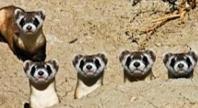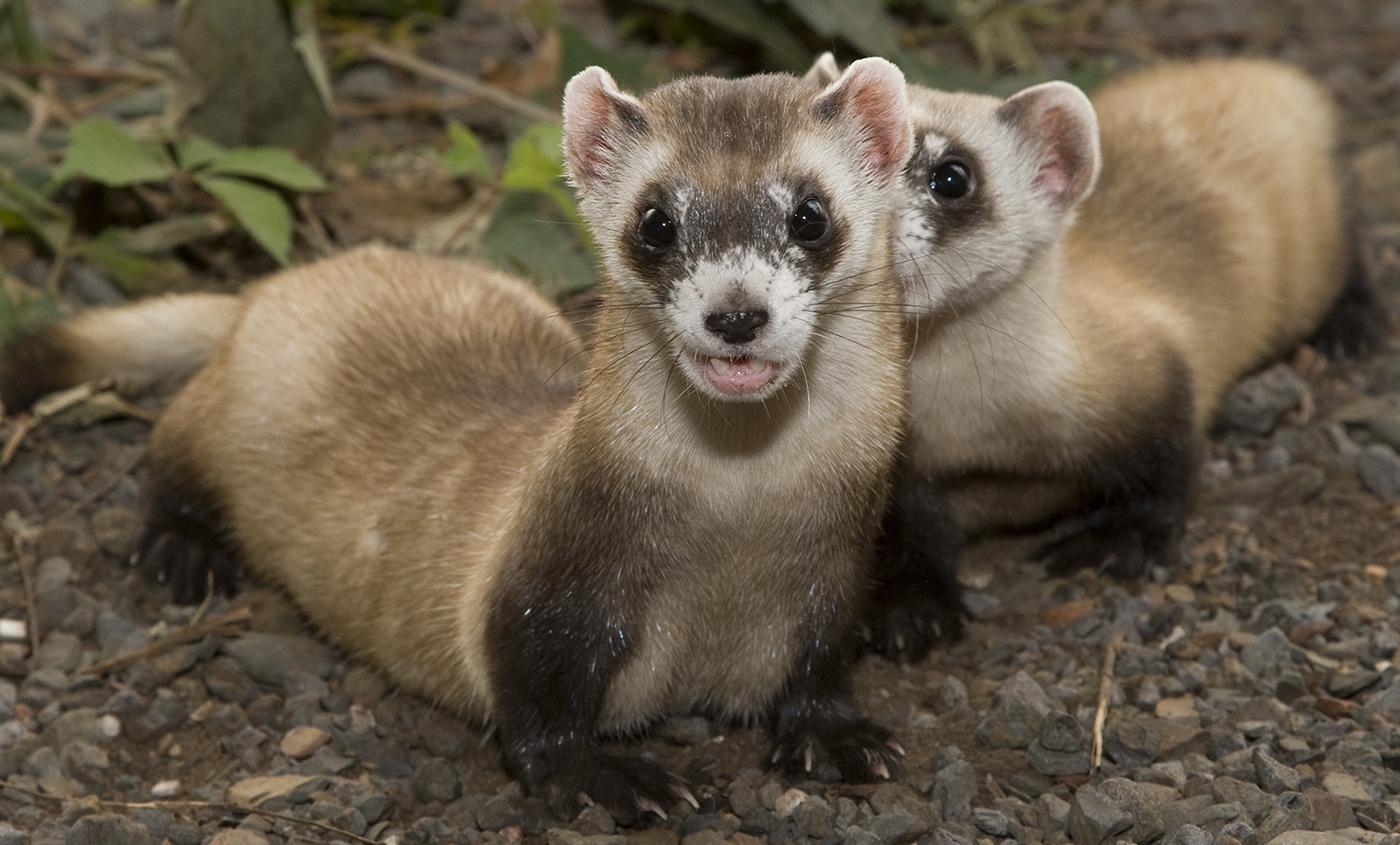The first image is the image on the left, the second image is the image on the right. Considering the images on both sides, is "At least one image has only one weasel." valid? Answer yes or no. No. The first image is the image on the left, the second image is the image on the right. Examine the images to the left and right. Is the description "There are at most four ferrets." accurate? Answer yes or no. No. 